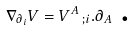Convert formula to latex. <formula><loc_0><loc_0><loc_500><loc_500>\nabla _ { \partial _ { i } } V = V ^ { A } \, _ { ; i } . \partial _ { A } \text { .}</formula> 